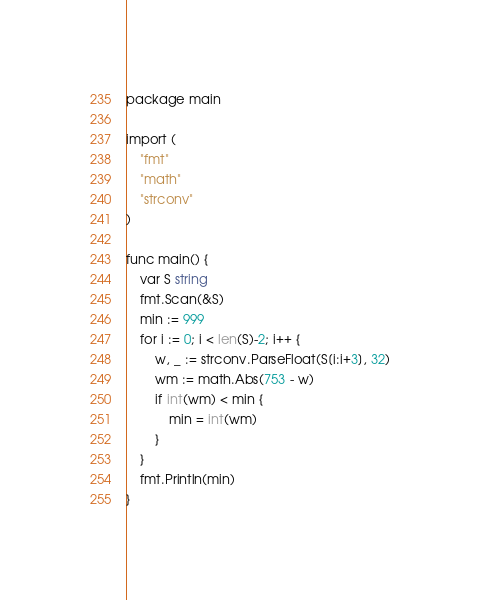<code> <loc_0><loc_0><loc_500><loc_500><_Go_>package main

import (
	"fmt"
	"math"
	"strconv"
)

func main() {
	var S string
	fmt.Scan(&S)
	min := 999
	for i := 0; i < len(S)-2; i++ {
		w, _ := strconv.ParseFloat(S[i:i+3], 32)
		wm := math.Abs(753 - w)
		if int(wm) < min {
			min = int(wm)
		}
	}
	fmt.Println(min)
}</code> 